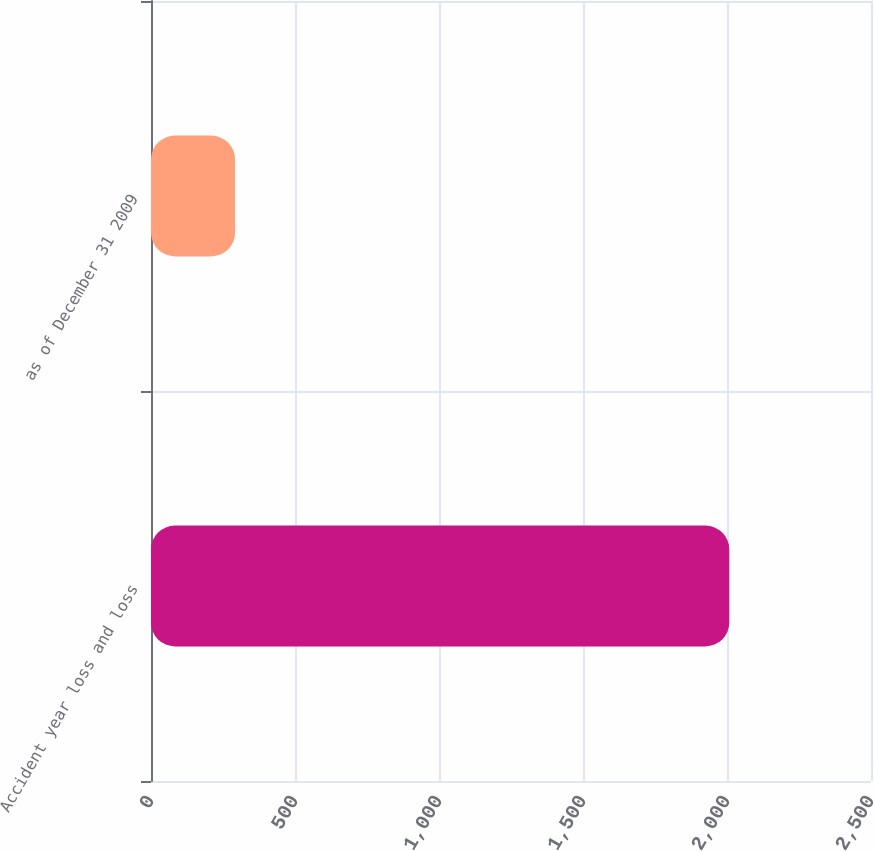Convert chart to OTSL. <chart><loc_0><loc_0><loc_500><loc_500><bar_chart><fcel>Accident year loss and loss<fcel>as of December 31 2009<nl><fcel>2008<fcel>292<nl></chart> 